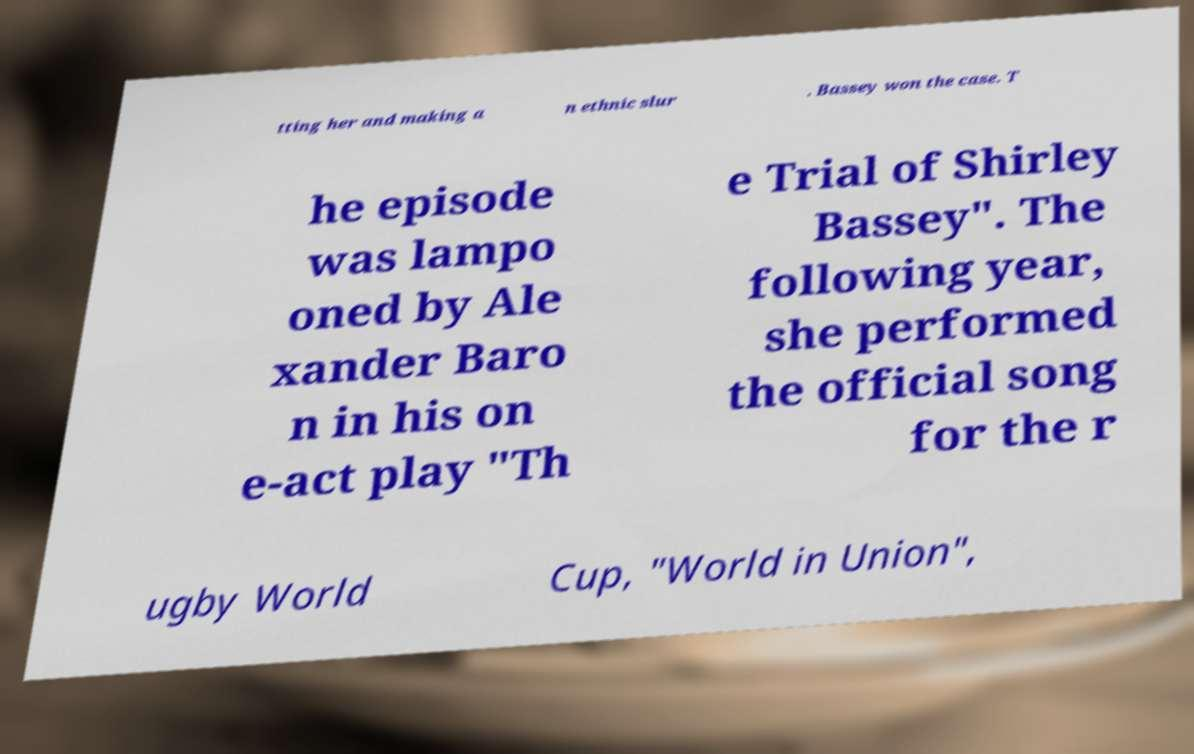There's text embedded in this image that I need extracted. Can you transcribe it verbatim? tting her and making a n ethnic slur . Bassey won the case. T he episode was lampo oned by Ale xander Baro n in his on e-act play "Th e Trial of Shirley Bassey". The following year, she performed the official song for the r ugby World Cup, "World in Union", 